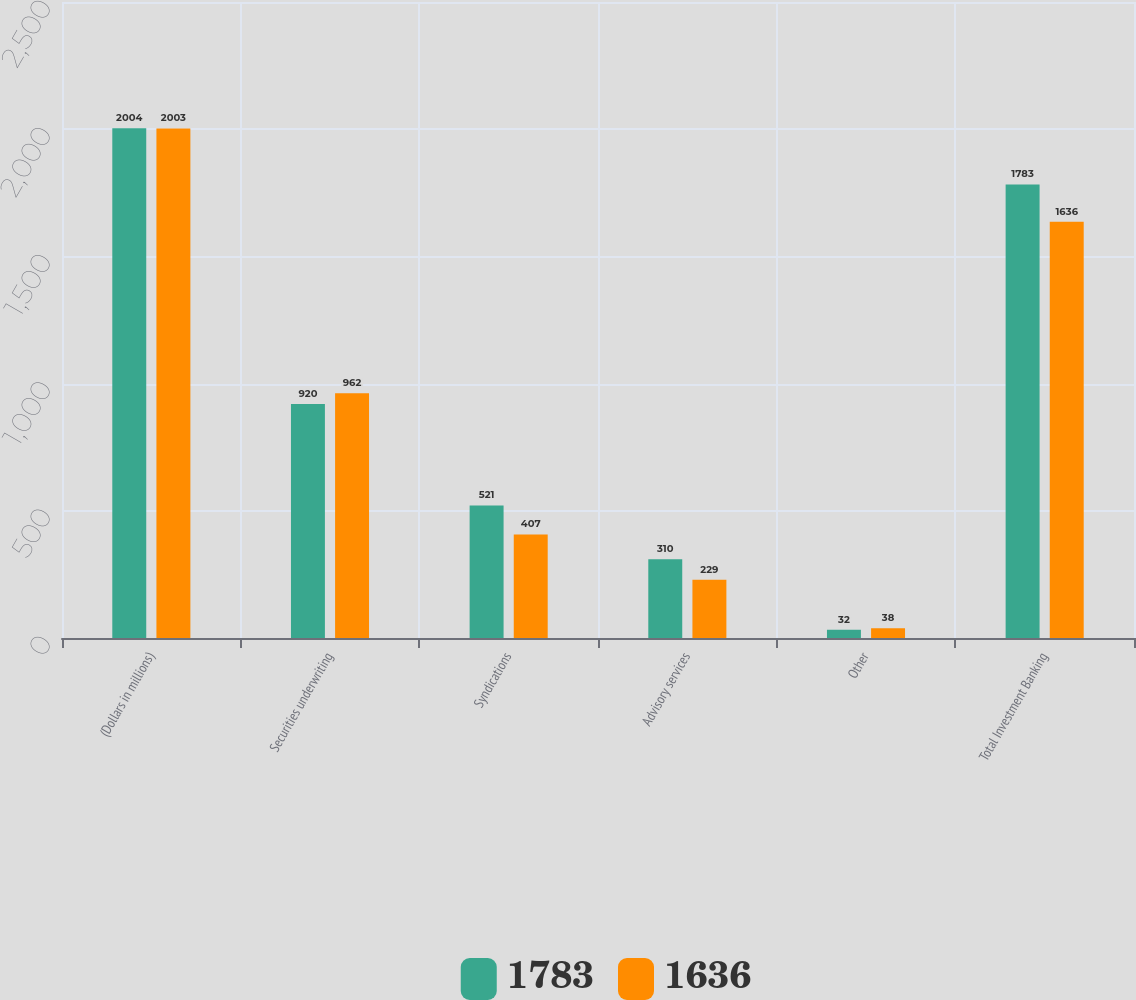Convert chart. <chart><loc_0><loc_0><loc_500><loc_500><stacked_bar_chart><ecel><fcel>(Dollars in millions)<fcel>Securities underwriting<fcel>Syndications<fcel>Advisory services<fcel>Other<fcel>Total Investment Banking<nl><fcel>1783<fcel>2004<fcel>920<fcel>521<fcel>310<fcel>32<fcel>1783<nl><fcel>1636<fcel>2003<fcel>962<fcel>407<fcel>229<fcel>38<fcel>1636<nl></chart> 